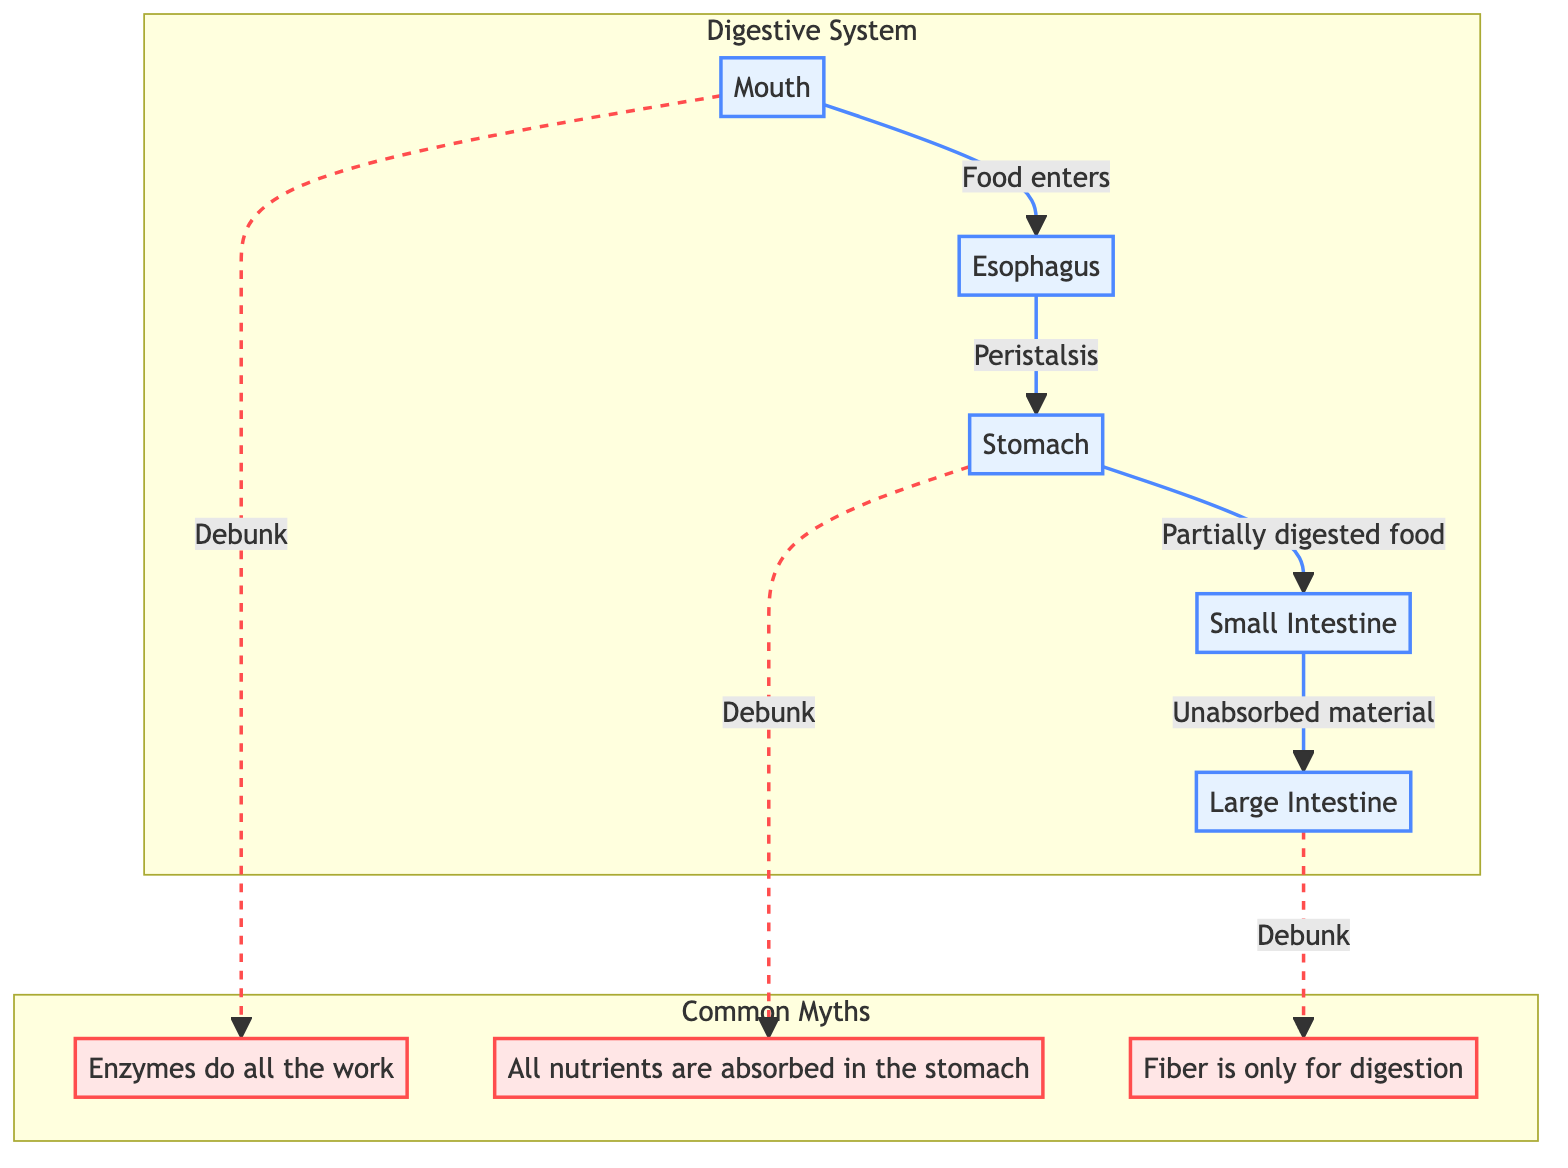What is the first organ in the human digestive pathway? The first organ mentioned in the diagram is the Mouth, which indicates where digestion begins.
Answer: Mouth How many main organs are shown in the digestive system? The diagram shows five main organs: Mouth, Esophagus, Stomach, Small Intestine, and Large Intestine.
Answer: Five What type of process is involved when food moves from the Esophagus to the Stomach? The movement of food from the Esophagus to the Stomach is through peristalsis, indicating a muscular contraction.
Answer: Peristalsis Which organ is primarily responsible for nutrient absorption? The Small Intestine is identified in the diagram as the major site of nutrient absorption, covering its role most specifically.
Answer: Small Intestine What myth is debunked related to the stomach's function? The myth debunked in the diagram is that all nutrients are absorbed in the stomach, clarifying that most absorption happens in the small intestine.
Answer: All nutrients are absorbed in the stomach Which type of nutrient supports gut health and regulates blood sugar, according to the myths? The diagram mentions fiber, highlighting its importance beyond digestion by indicating its role in gut health and blood sugar regulation.
Answer: Fiber In the context of the flowchart, where does food become mixed with gastric juices? According to the diagram, food becomes mixed with gastric juices in the Stomach, showing where significant chemical digestion occurs.
Answer: Stomach What is the relationship between the Large Intestine and waste? The diagram indicates that the Large Intestine absorbs water and electrolytes and prepares waste for elimination, showing its final processing role.
Answer: Prepares waste for elimination How is chewing categorized in the digestion process according to this flowchart? Chewing is classified as a mechanical process in the Mouth, emphasizing its role in the initial stages of digestion alongside enzymatic actions.
Answer: Mechanical process 